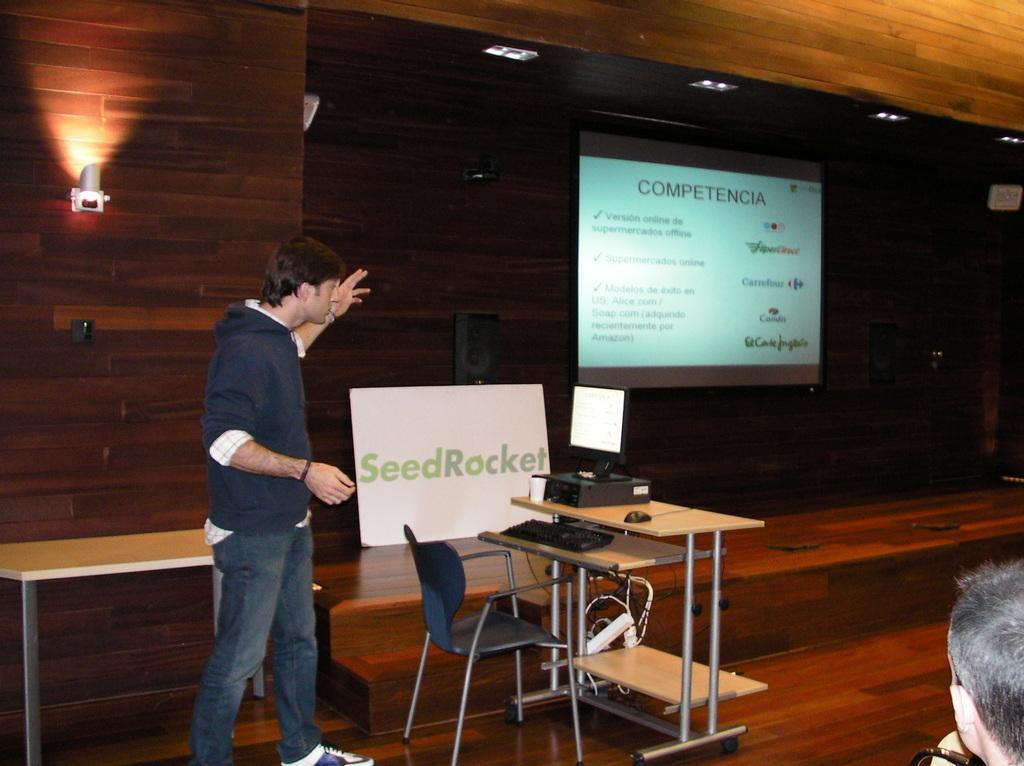Describe this image in one or two sentences. In this image I can see a person standing wearing blue shirt, blue pant. I can also see a system on the table and the table is in brown color, and I can also see a chair in blue color. Background I can see a projector screen, few lights and wooden wall. 